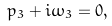Convert formula to latex. <formula><loc_0><loc_0><loc_500><loc_500>p _ { 3 } + i \omega _ { 3 } = 0 ,</formula> 